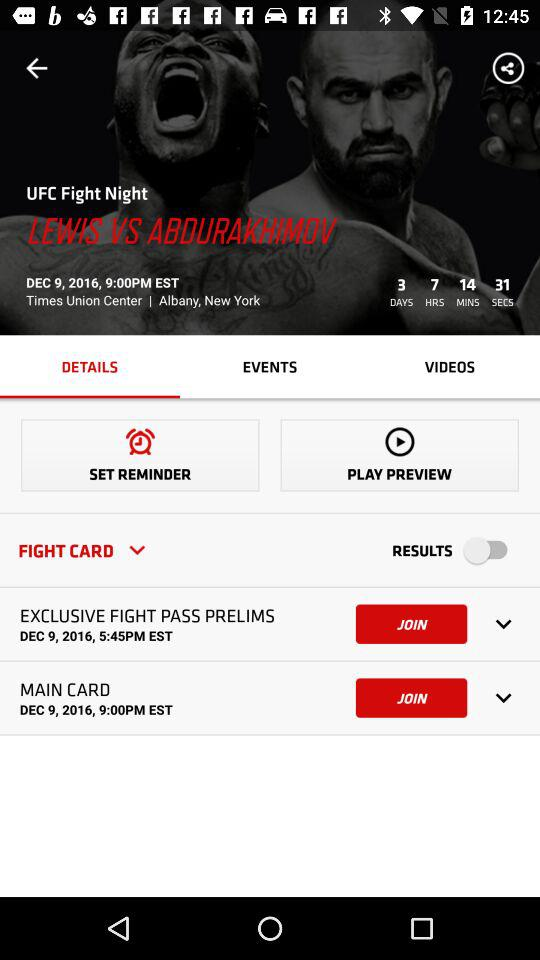How many items are in the fight card?
Answer the question using a single word or phrase. 2 